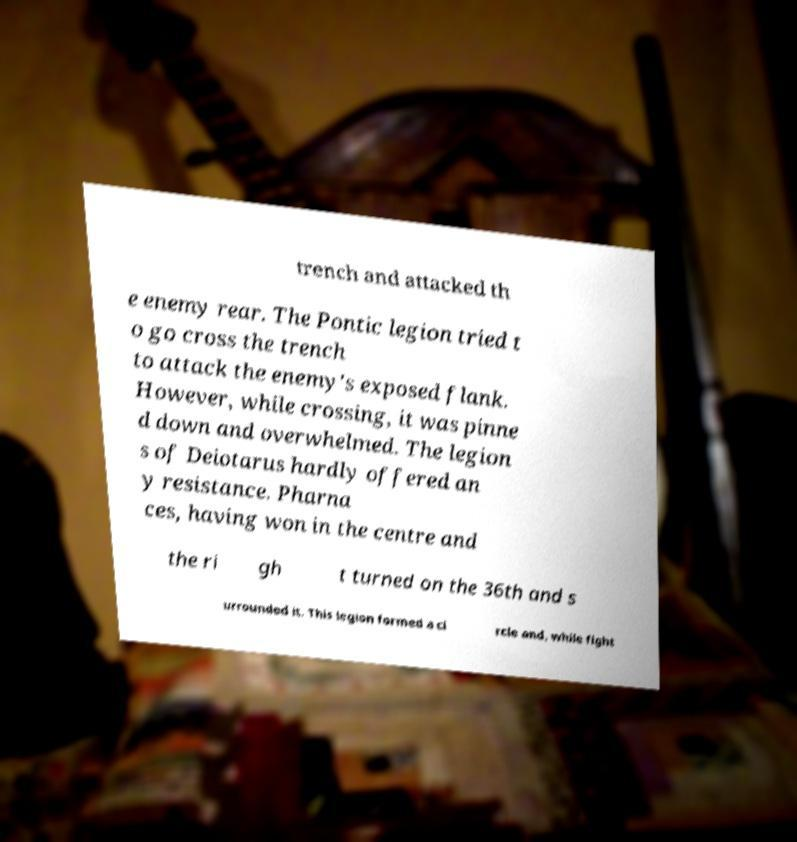There's text embedded in this image that I need extracted. Can you transcribe it verbatim? trench and attacked th e enemy rear. The Pontic legion tried t o go cross the trench to attack the enemy's exposed flank. However, while crossing, it was pinne d down and overwhelmed. The legion s of Deiotarus hardly offered an y resistance. Pharna ces, having won in the centre and the ri gh t turned on the 36th and s urrounded it. This legion formed a ci rcle and, while fight 